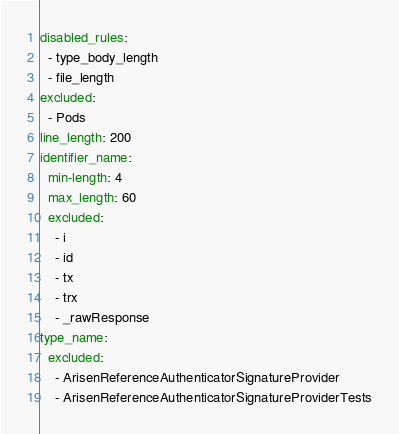<code> <loc_0><loc_0><loc_500><loc_500><_YAML_>disabled_rules:
  - type_body_length
  - file_length
excluded:
  - Pods
line_length: 200
identifier_name:
  min-length: 4
  max_length: 60
  excluded:
    - i
    - id
    - tx
    - trx
    - _rawResponse
type_name:
  excluded:
    - ArisenReferenceAuthenticatorSignatureProvider
    - ArisenReferenceAuthenticatorSignatureProviderTests
</code> 